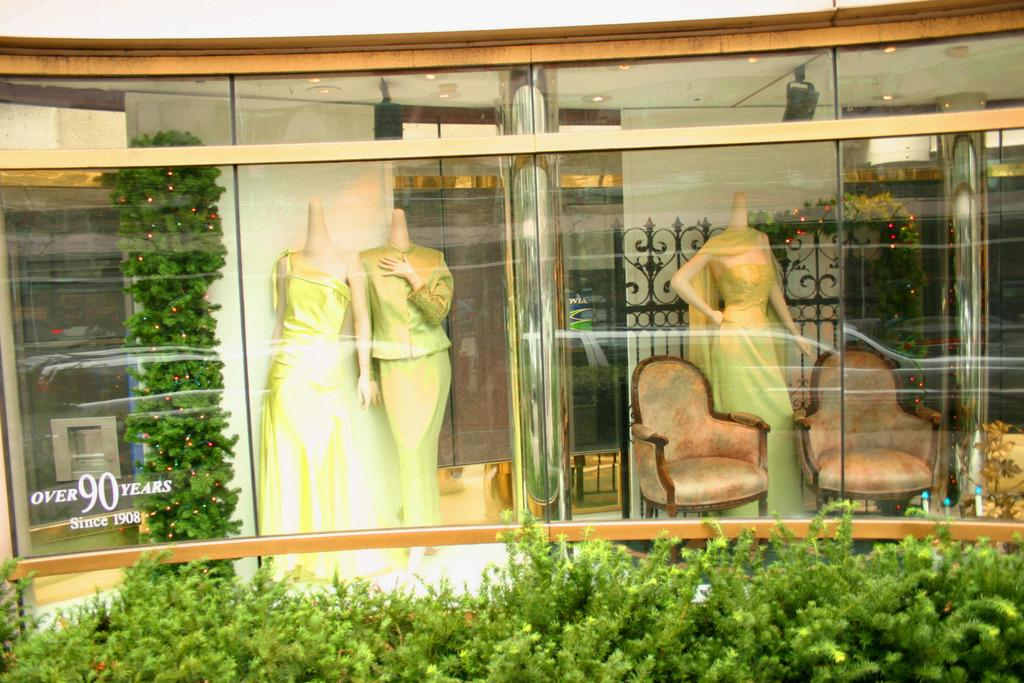What is located in front of the picture? There are plants in front of the picture. What can be seen through the glass in the image? There are mannequins visible through the glass. How many chairs are present in the image? There are two empty chairs in the image. What type of light is being used to illuminate the mannequins in the image? There is no specific information about the type of light being used in the image, as it is not mentioned in the provided facts. 